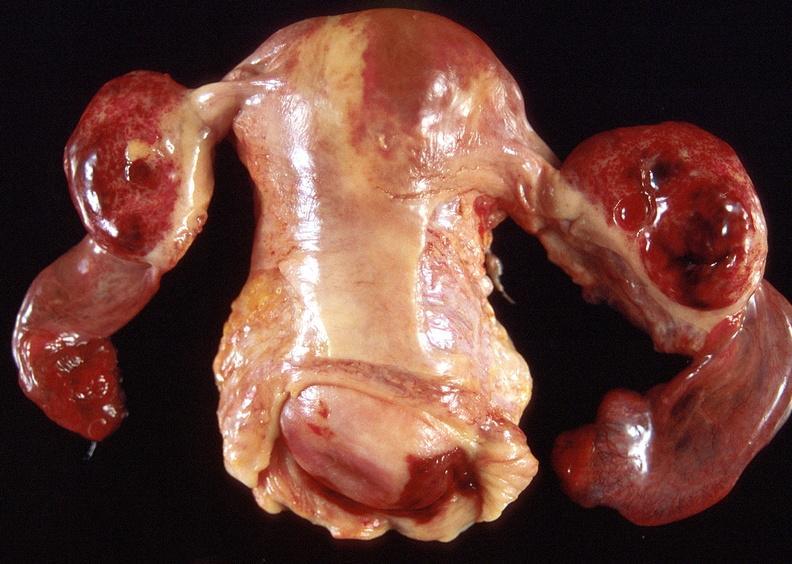where does this part belong to?
Answer the question using a single word or phrase. Female reproductive system 